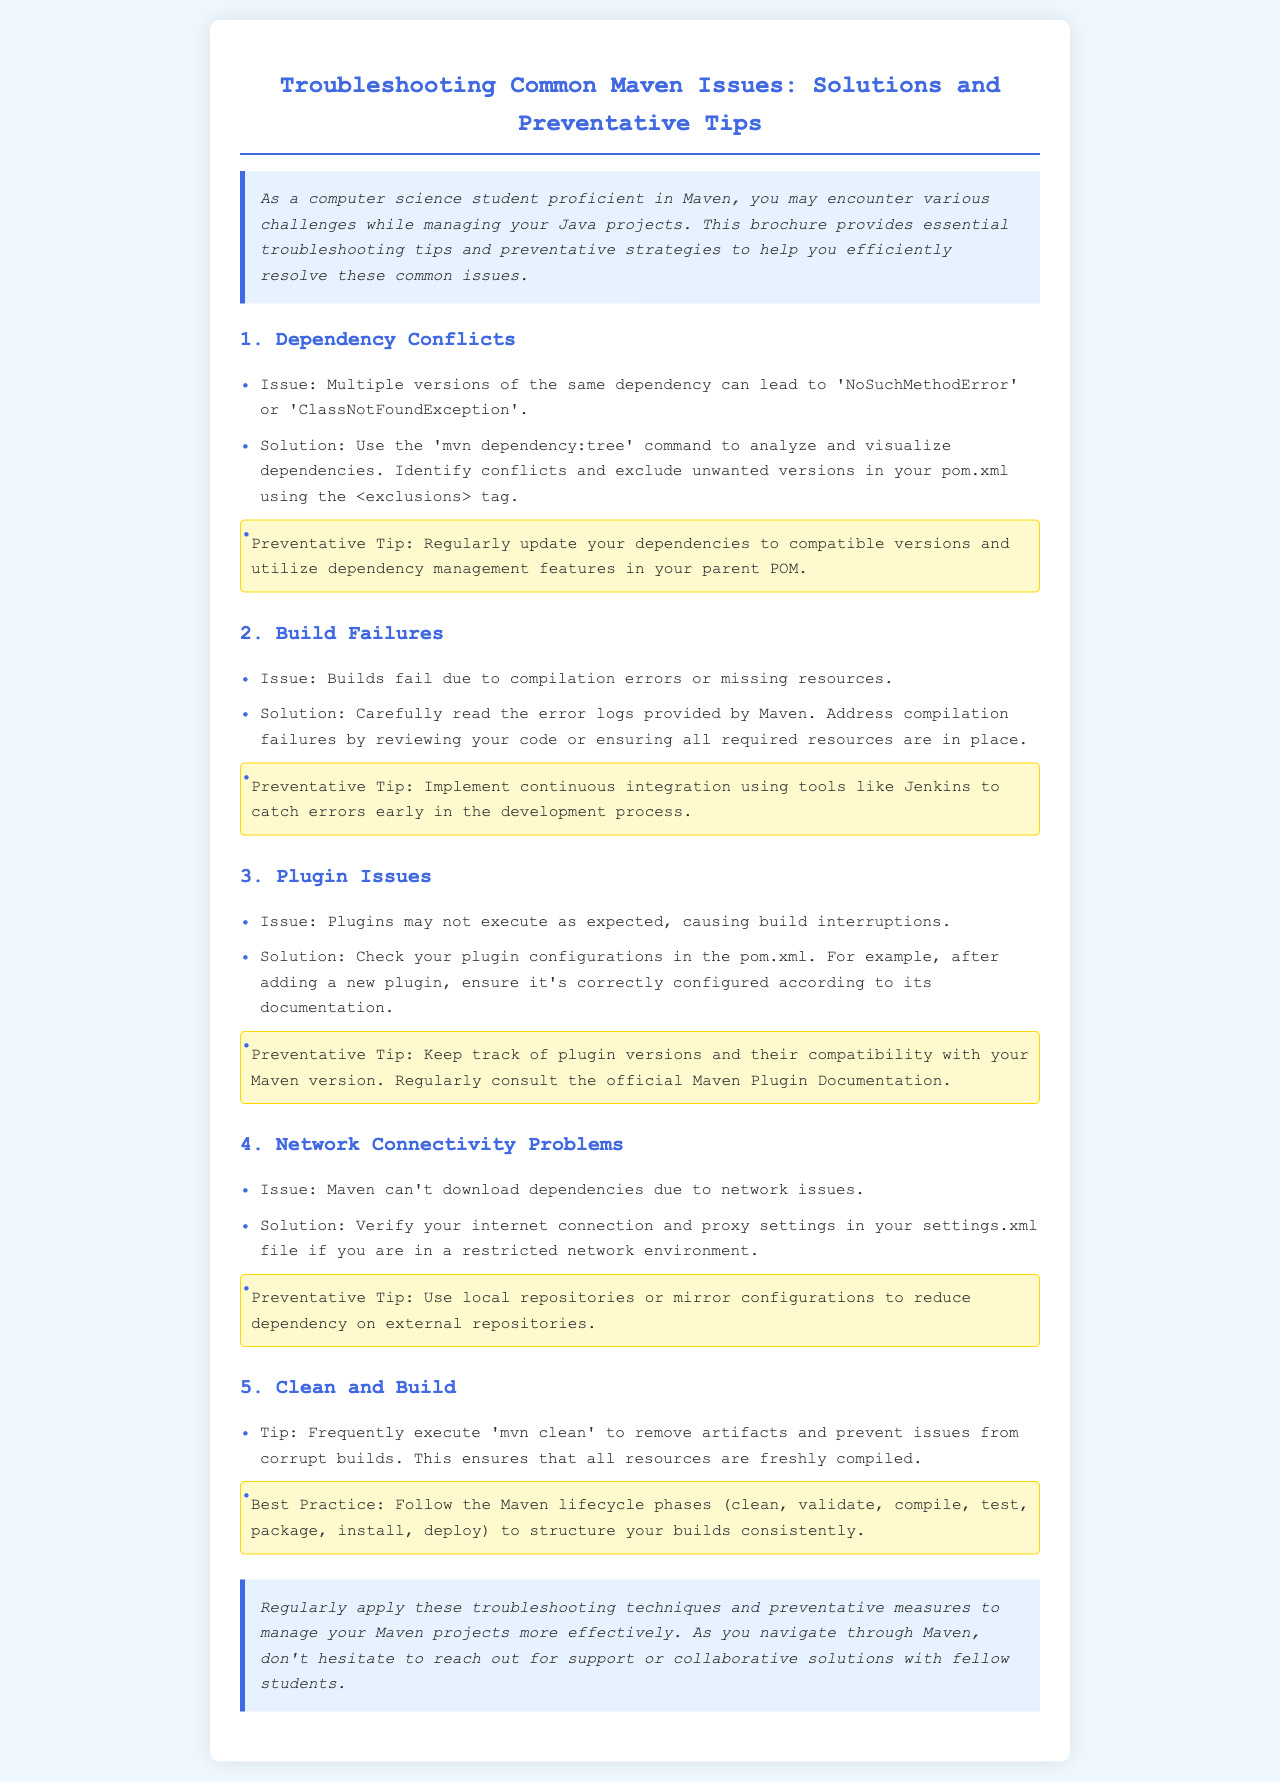What is the title of the brochure? The title is stated at the top of the document in a prominent position.
Answer: Troubleshooting Common Maven Issues: Solutions and Preventative Tips What is the first issue mentioned related to Maven? The issues are listed in order, starting from the first one mentioned under section headings.
Answer: Dependency Conflicts What command is suggested to analyze dependencies? The document provides specific commands and solutions for each issue categorized.
Answer: mvn dependency:tree What preventative tip is recommended for dependency conflicts? Each issue is paired with a preventative tip to avoid future occurrences.
Answer: Regularly update your dependencies What type of issue can occur due to compilation errors? The document specifies various types of failures and their related causes.
Answer: Build Failures What is a recommended solution for plugin issues? The document outlines solutions to several issues, including specific actions to take.
Answer: Check your plugin configurations Which tip is provided to manage network connectivity problems? Each section offers solutions along with tips aimed at preventing future issues.
Answer: Use local repositories or mirror configurations What practice is suggested to ensure builds are structured consistently? Best practices are listed towards the end of the document, detailing how to proceed with builds.
Answer: Follow the Maven lifecycle phases How does the brochure suggest you handle corrupt builds? Tips are given specifically for cleaning and building correctly.
Answer: Frequently execute mvn clean 